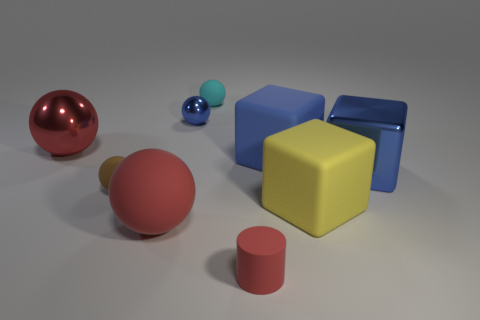Subtract all large matte blocks. How many blocks are left? 1 Subtract all brown balls. How many balls are left? 4 Subtract 1 blocks. How many blocks are left? 2 Subtract all green cubes. How many red spheres are left? 2 Subtract all cylinders. How many objects are left? 8 Subtract all cyan cylinders. Subtract all red balls. How many cylinders are left? 1 Subtract all rubber things. Subtract all large brown metallic objects. How many objects are left? 3 Add 8 brown matte balls. How many brown matte balls are left? 9 Add 7 big gray rubber cylinders. How many big gray rubber cylinders exist? 7 Subtract 0 yellow cylinders. How many objects are left? 9 